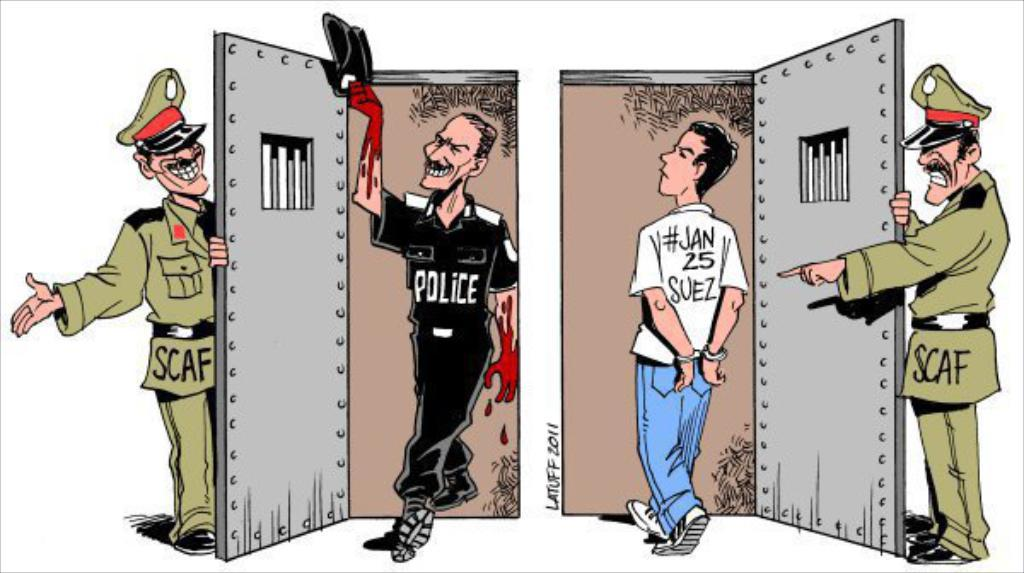What type of images are present in the picture? There are cartoon pictures of a man in the image. How is the man depicted in the cartoon images? The man is depicted in different costumes. What type of goldfish can be seen swimming in the image? There are no goldfish present in the image; it only contains cartoon pictures of a man in different costumes. 